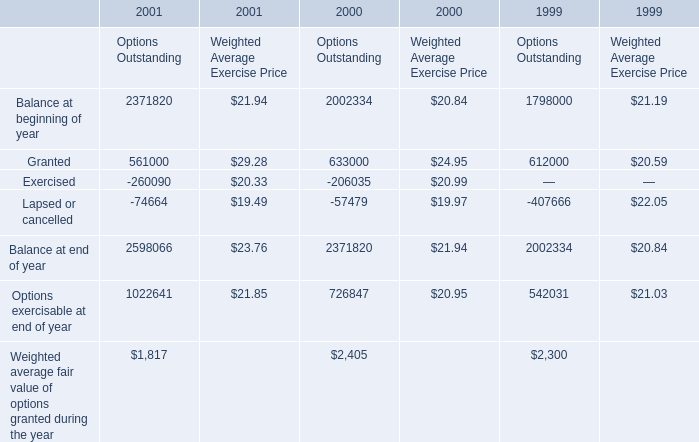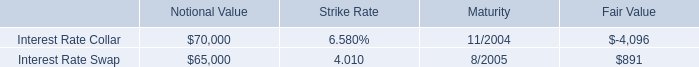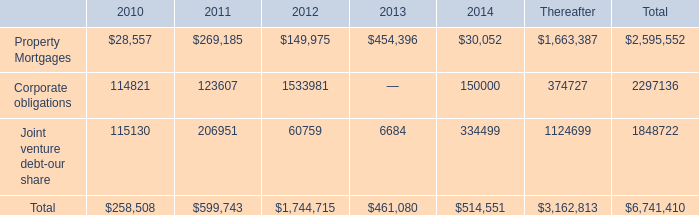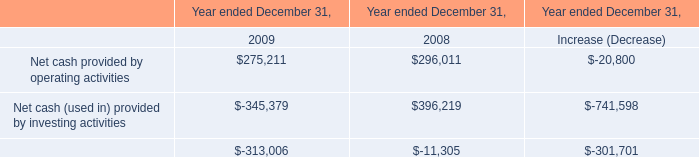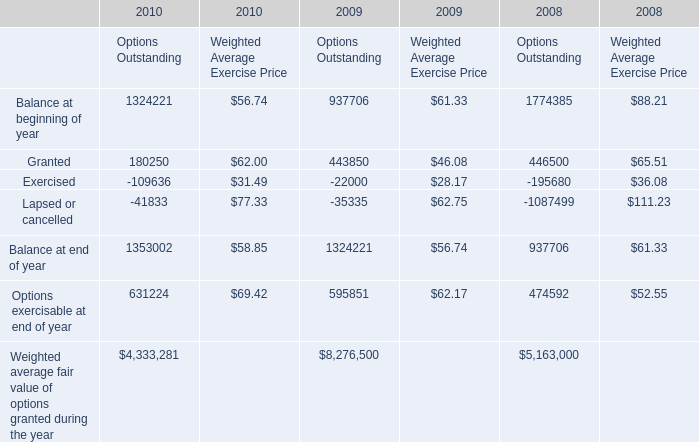What's the sum of Exercised of 2000 Options Outstanding, and Lapsed or cancelled of 2008 Options Outstanding ? 
Computations: (206035.0 + 1087499.0)
Answer: 1293534.0. 